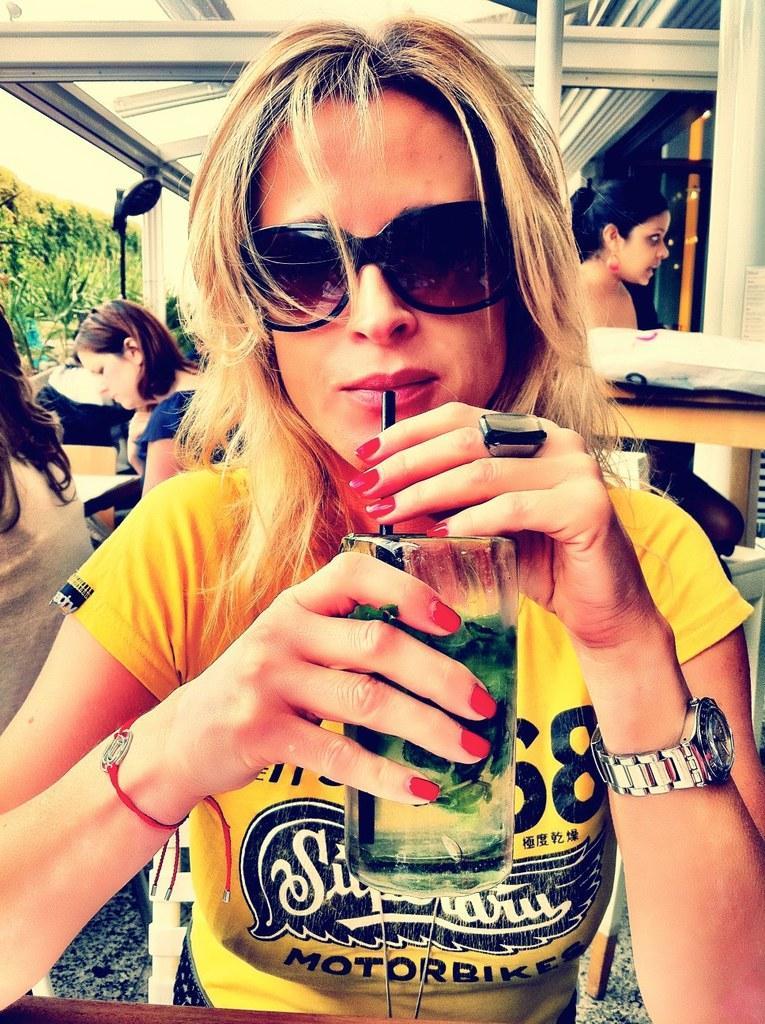Can you describe this image briefly? In the middle of the image a woman is sitting and holding a glass and watching. Behind her few people are sitting and there are some chairs and tables. Top of the image there is roof. Top left side of the image there are some trees. 